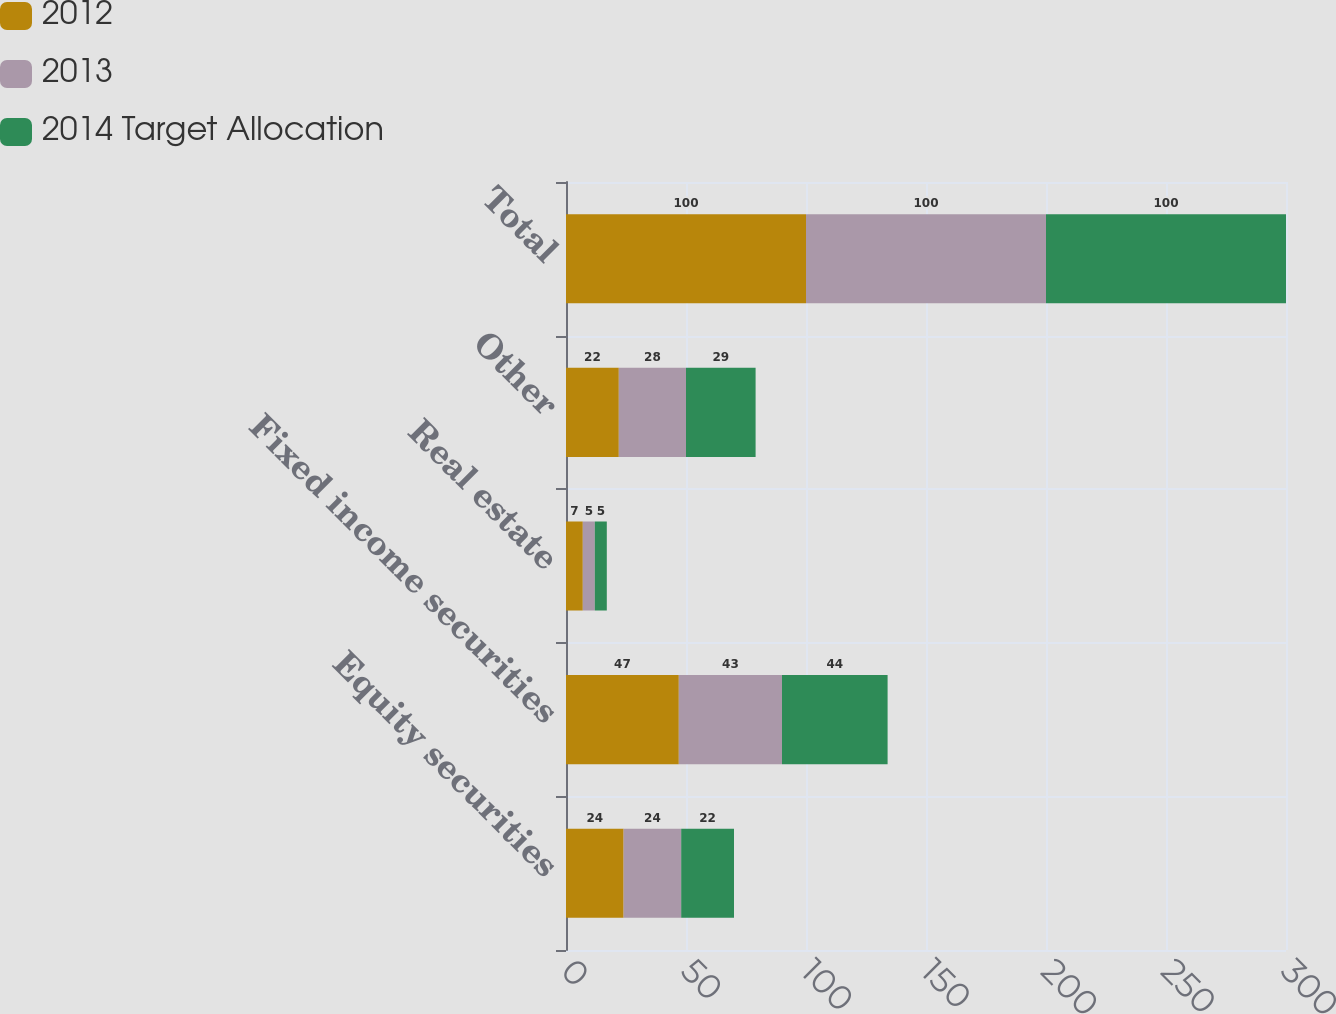Convert chart to OTSL. <chart><loc_0><loc_0><loc_500><loc_500><stacked_bar_chart><ecel><fcel>Equity securities<fcel>Fixed income securities<fcel>Real estate<fcel>Other<fcel>Total<nl><fcel>2012<fcel>24<fcel>47<fcel>7<fcel>22<fcel>100<nl><fcel>2013<fcel>24<fcel>43<fcel>5<fcel>28<fcel>100<nl><fcel>2014 Target Allocation<fcel>22<fcel>44<fcel>5<fcel>29<fcel>100<nl></chart> 